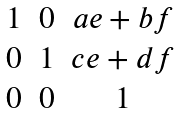Convert formula to latex. <formula><loc_0><loc_0><loc_500><loc_500>\begin{matrix} 1 & 0 & a e + b f \\ 0 & 1 & c e + d f \\ 0 & 0 & 1 \end{matrix}</formula> 